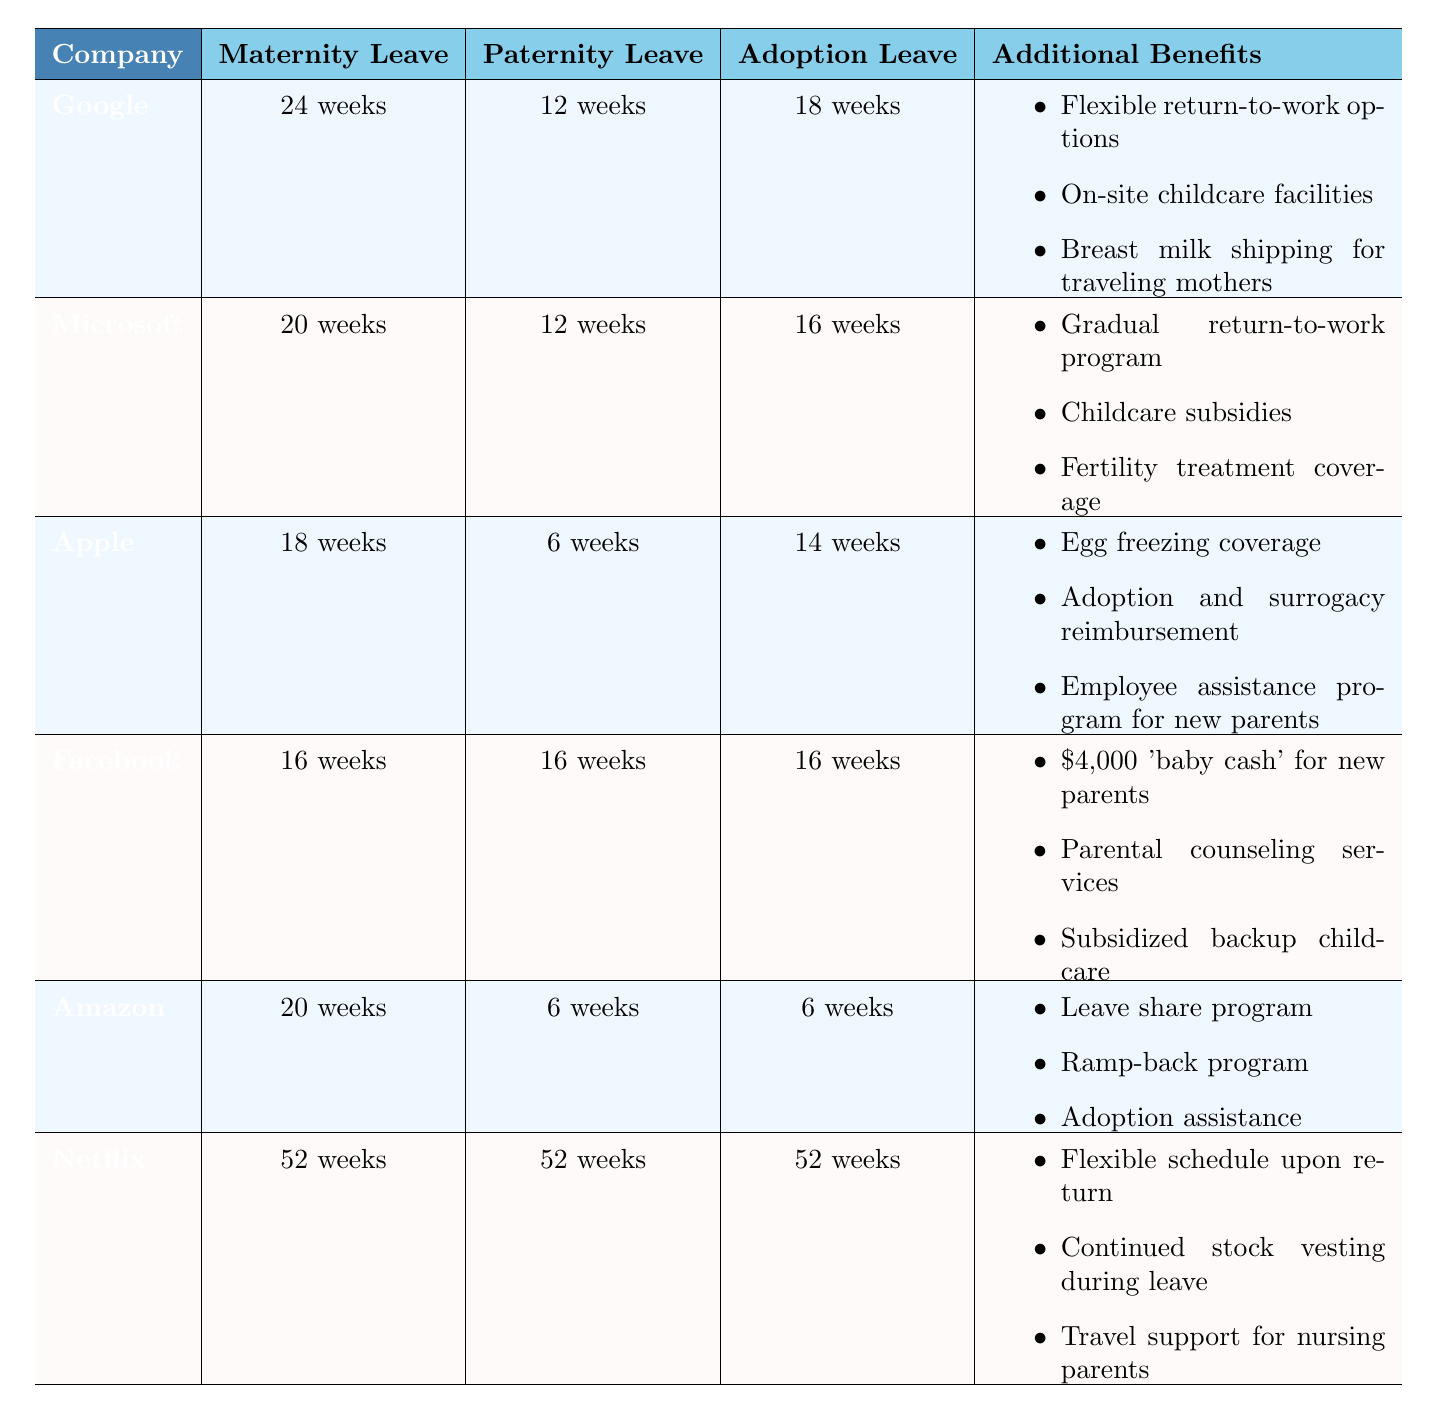What is the maternity leave duration for Google? The table shows that Google's maternity leave policy allows for 24 weeks of leave.
Answer: 24 weeks Which company offers the shortest maternity leave? According to the table, Apple offers the shortest maternity leave duration at 18 weeks.
Answer: Apple How many weeks of paternity leave does Facebook provide? The table indicates that Facebook provides 16 weeks of paternity leave.
Answer: 16 weeks What is the total leave duration offered for adoption by Netflix? Netflix provides 52 weeks of adoption leave, as stated in the table.
Answer: 52 weeks Is the paternity leave at Apple longer than that at Amazon? The table shows that Apple offers 6 weeks of paternity leave and Amazon also offers 6 weeks, making them equal in duration.
Answer: No Compare the maternity leave for Microsoft and Amazon. Which is longer and by how much? Microsoft offers 20 weeks of maternity leave, whereas Amazon offers 20 weeks as well. Therefore, their maternity leave durations are equal.
Answer: Equal Which company has the most extensive additional benefits listed? The table indicates that Netflix has the most extensive additional benefits, with three specific items compared to those of other companies.
Answer: Netflix How does Facebook's maternity leave compare to Microsoft's? Facebook offers 16 weeks while Microsoft offers 20 weeks, making Microsoft's maternity leave longer by 4 weeks.
Answer: Microsoft is longer by 4 weeks What is the average maternity leave duration among the companies listed? The maternity leave durations for all companies are 24, 20, 18, 16, 20, and 52 weeks. Adding these gives a total of 150 weeks, and dividing by 6 gives an average of 25 weeks.
Answer: 25 weeks Which company provides paternity leave equal to its maternity leave duration? The table shows that Facebook offers 16 weeks of both maternity and paternity leave, indicating equality.
Answer: Facebook 